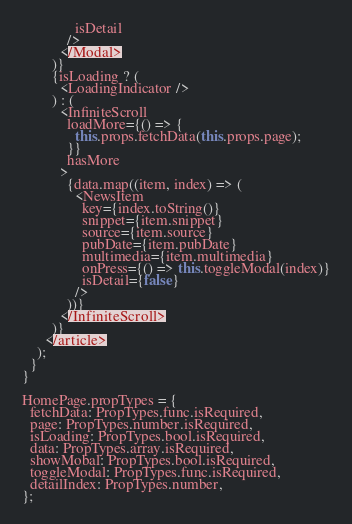<code> <loc_0><loc_0><loc_500><loc_500><_JavaScript_>              isDetail
            />
          </Modal>
        )}
        {isLoading ? (
          <LoadingIndicator />
        ) : (
          <InfiniteScroll
            loadMore={() => {
              this.props.fetchData(this.props.page);
            }}
            hasMore
          >
            {data.map((item, index) => (
              <NewsItem
                key={index.toString()}
                snippet={item.snippet}
                source={item.source}
                pubDate={item.pubDate}
                multimedia={item.multimedia}
                onPress={() => this.toggleModal(index)}
                isDetail={false}
              />
            ))}
          </InfiniteScroll>
        )}
      </article>
    );
  }
}

HomePage.propTypes = {
  fetchData: PropTypes.func.isRequired,
  page: PropTypes.number.isRequired,
  isLoading: PropTypes.bool.isRequired,
  data: PropTypes.array.isRequired,
  showMobal: PropTypes.bool.isRequired,
  toggleModal: PropTypes.func.isRequired,
  detailIndex: PropTypes.number,
};
</code> 